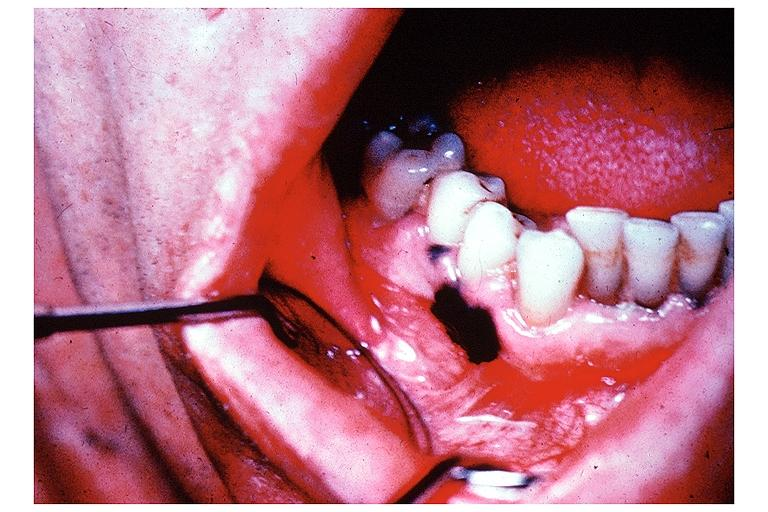does this image show melanoma?
Answer the question using a single word or phrase. Yes 